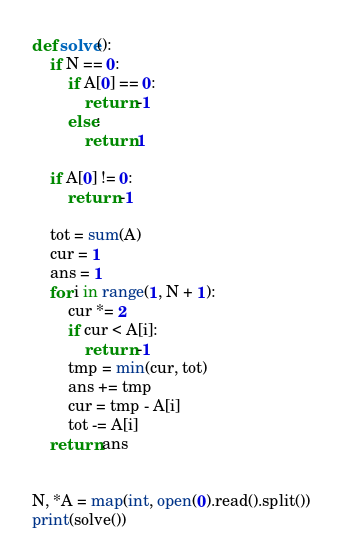<code> <loc_0><loc_0><loc_500><loc_500><_Python_>def solve():
    if N == 0:
        if A[0] == 0:
            return -1
        else:
            return 1

    if A[0] != 0:
        return -1

    tot = sum(A)
    cur = 1
    ans = 1
    for i in range(1, N + 1):
        cur *= 2
        if cur < A[i]:
            return -1
        tmp = min(cur, tot)
        ans += tmp
        cur = tmp - A[i]
        tot -= A[i]
    return ans


N, *A = map(int, open(0).read().split())
print(solve())
</code> 